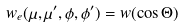<formula> <loc_0><loc_0><loc_500><loc_500>w _ { e } ( \mu , \mu ^ { \prime } , \phi , \phi ^ { \prime } ) = w ( \cos \Theta )</formula> 